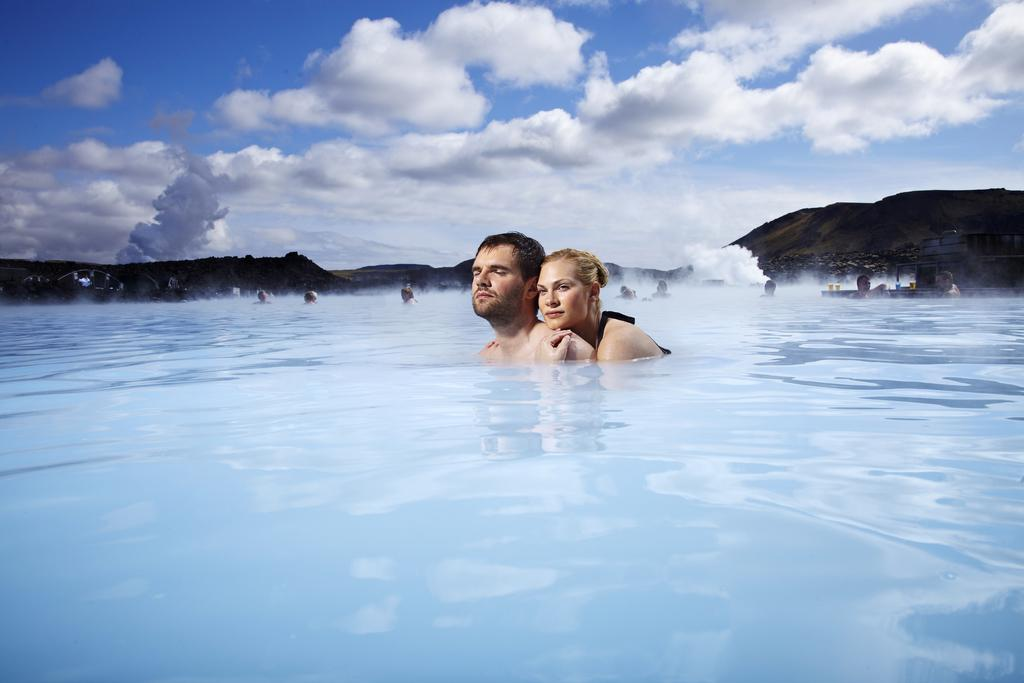What are the two people in the image doing? There is a man and a lady in the water in the image. Can you describe the people in the background of the image? There are people in the background of the image. What can be seen in the distance behind the people in the water? There are hills visible in the background of the image. What is visible above the hills and people in the image? The sky is visible in the background of the image. What type of juice is being served during the war in the image? There is no mention of juice or war in the image; it features a man and a lady in the water with people and hills in the background. 